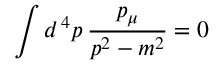Convert formula to latex. <formula><loc_0><loc_0><loc_500><loc_500>\int d ^ { \, 4 } p \, { \frac { p _ { \mu } } { p ^ { 2 } - m ^ { 2 } } } = 0</formula> 